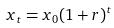Convert formula to latex. <formula><loc_0><loc_0><loc_500><loc_500>x _ { t } = x _ { 0 } ( 1 + r ) ^ { t }</formula> 